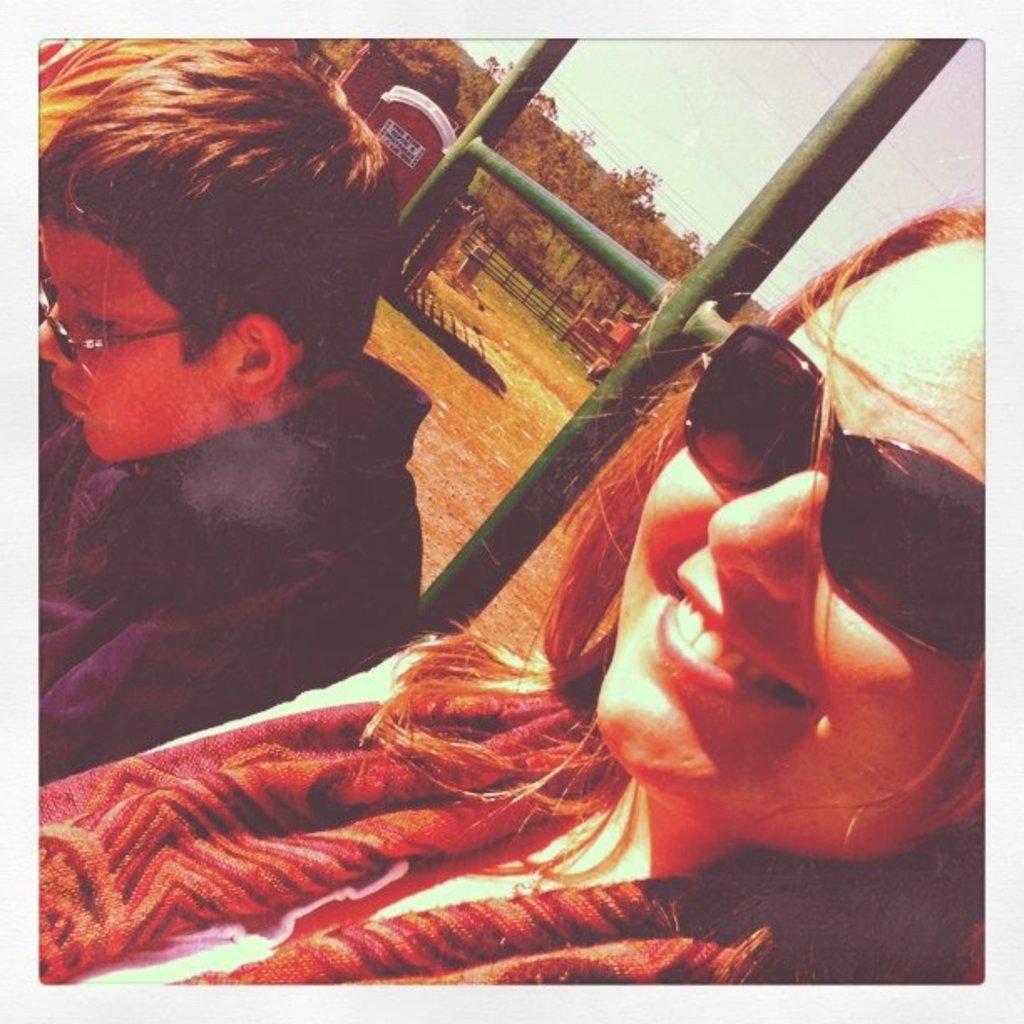Could you give a brief overview of what you see in this image? In this image we can see two persons, behind them there is a wooden house, we can see some trees and a fencing and we can able to see sky. 